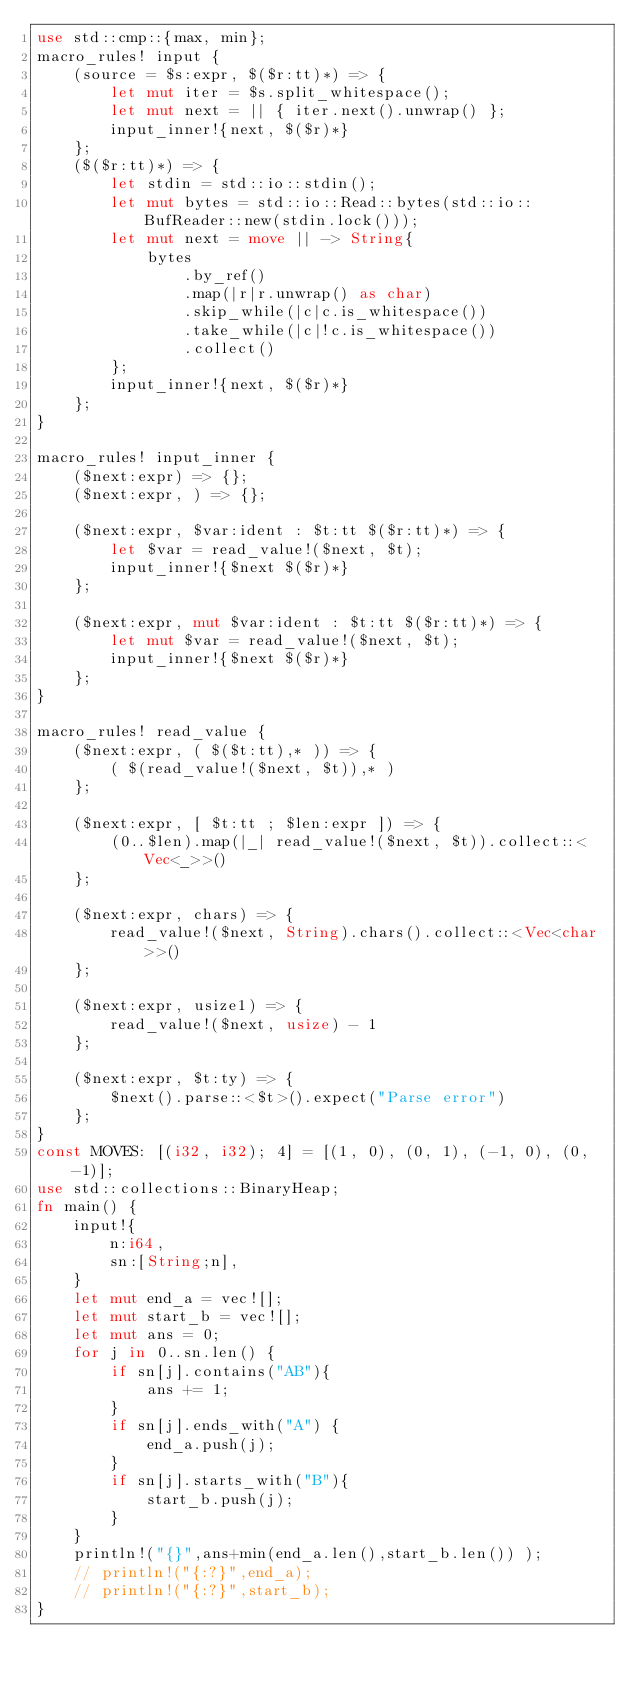<code> <loc_0><loc_0><loc_500><loc_500><_Rust_>use std::cmp::{max, min};
macro_rules! input {
    (source = $s:expr, $($r:tt)*) => {
        let mut iter = $s.split_whitespace();
        let mut next = || { iter.next().unwrap() };
        input_inner!{next, $($r)*}
    };
    ($($r:tt)*) => {
        let stdin = std::io::stdin();
        let mut bytes = std::io::Read::bytes(std::io::BufReader::new(stdin.lock()));
        let mut next = move || -> String{
            bytes
                .by_ref()
                .map(|r|r.unwrap() as char)
                .skip_while(|c|c.is_whitespace())
                .take_while(|c|!c.is_whitespace())
                .collect()
        };
        input_inner!{next, $($r)*}
    };
}

macro_rules! input_inner {
    ($next:expr) => {};
    ($next:expr, ) => {};

    ($next:expr, $var:ident : $t:tt $($r:tt)*) => {
        let $var = read_value!($next, $t);
        input_inner!{$next $($r)*}
    };

    ($next:expr, mut $var:ident : $t:tt $($r:tt)*) => {
        let mut $var = read_value!($next, $t);
        input_inner!{$next $($r)*}
    };
}

macro_rules! read_value {
    ($next:expr, ( $($t:tt),* )) => {
        ( $(read_value!($next, $t)),* )
    };

    ($next:expr, [ $t:tt ; $len:expr ]) => {
        (0..$len).map(|_| read_value!($next, $t)).collect::<Vec<_>>()
    };

    ($next:expr, chars) => {
        read_value!($next, String).chars().collect::<Vec<char>>()
    };

    ($next:expr, usize1) => {
        read_value!($next, usize) - 1
    };

    ($next:expr, $t:ty) => {
        $next().parse::<$t>().expect("Parse error")
    };
}
const MOVES: [(i32, i32); 4] = [(1, 0), (0, 1), (-1, 0), (0, -1)];
use std::collections::BinaryHeap;
fn main() {
    input!{
        n:i64,
        sn:[String;n],
    }
    let mut end_a = vec![];
    let mut start_b = vec![];
    let mut ans = 0;
    for j in 0..sn.len() {
        if sn[j].contains("AB"){
            ans += 1;
        }
        if sn[j].ends_with("A") {
            end_a.push(j);
        }
        if sn[j].starts_with("B"){
            start_b.push(j);
        }
    }
    println!("{}",ans+min(end_a.len(),start_b.len()) );
    // println!("{:?}",end_a);
    // println!("{:?}",start_b);
}
</code> 